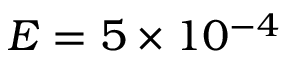<formula> <loc_0><loc_0><loc_500><loc_500>E = 5 \times 1 0 ^ { - 4 }</formula> 